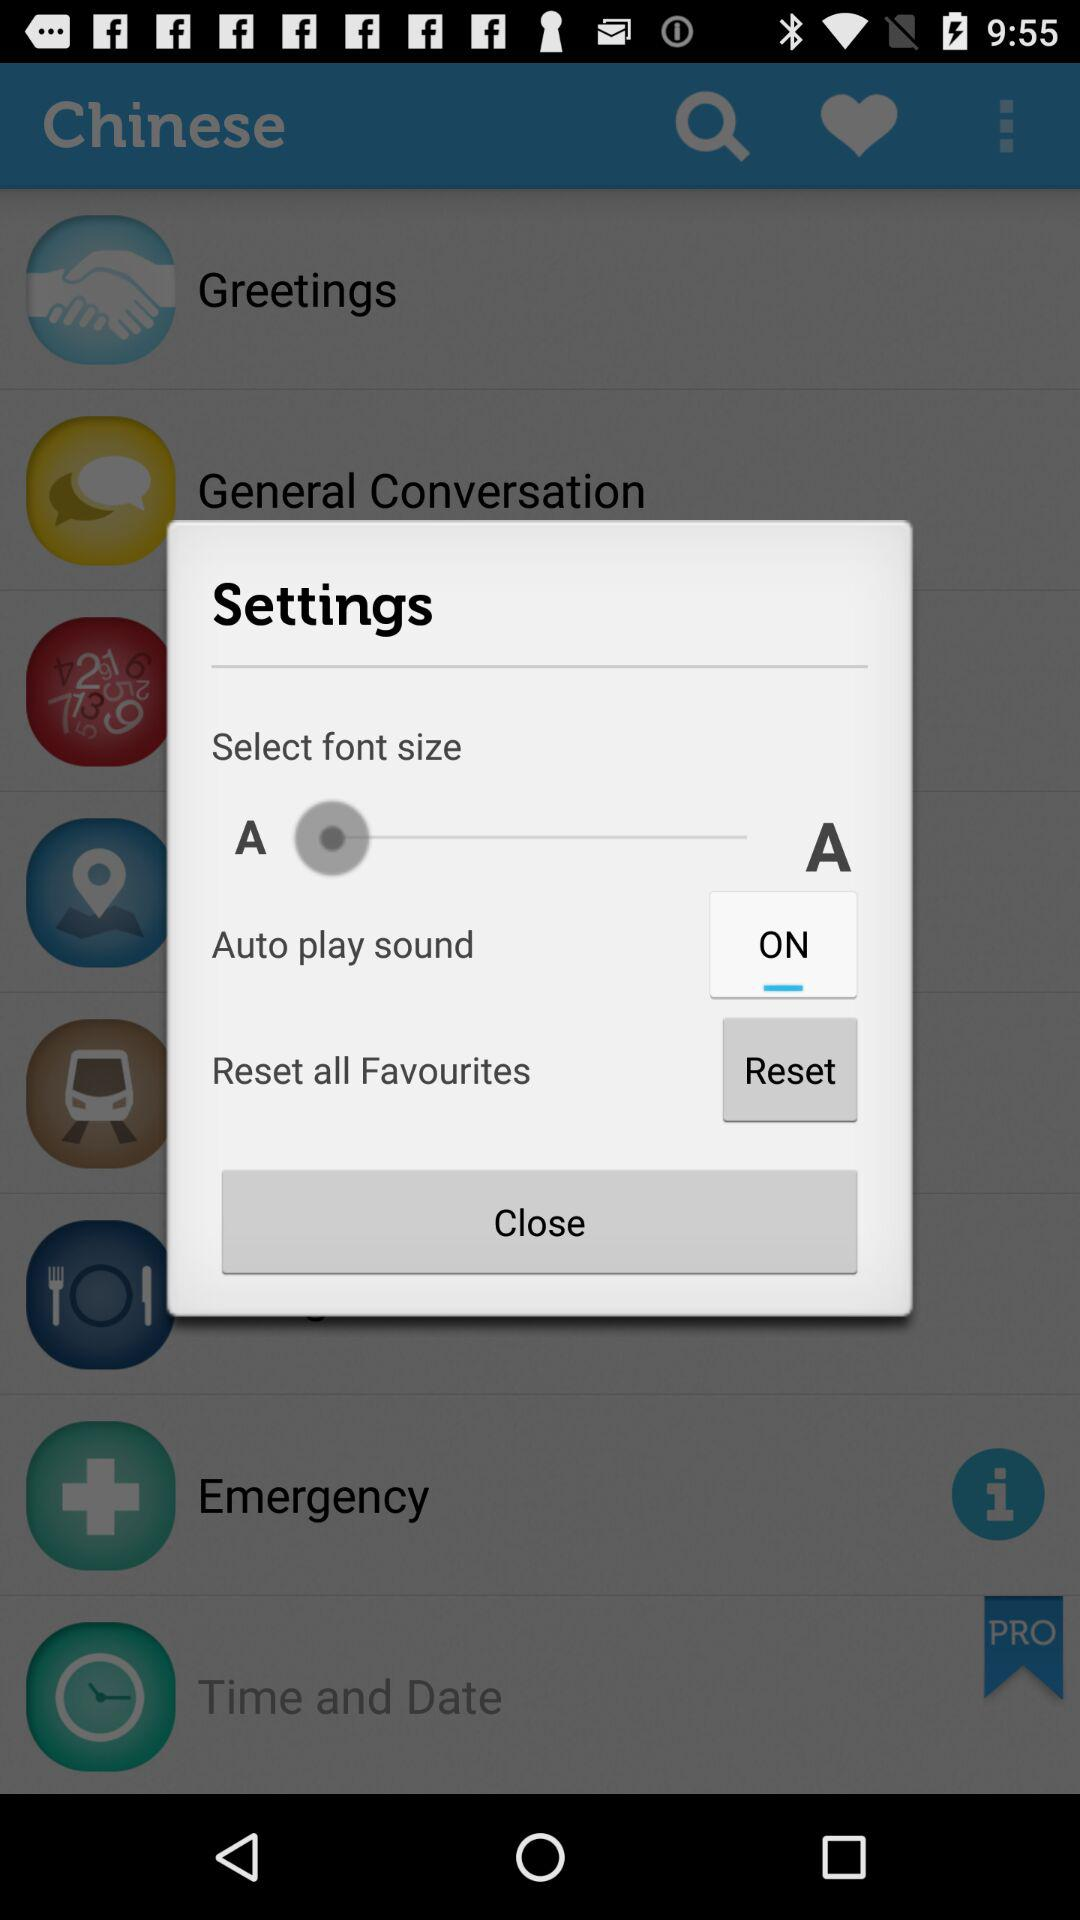What's the status of "Auto play sound"? The status is "ON". 